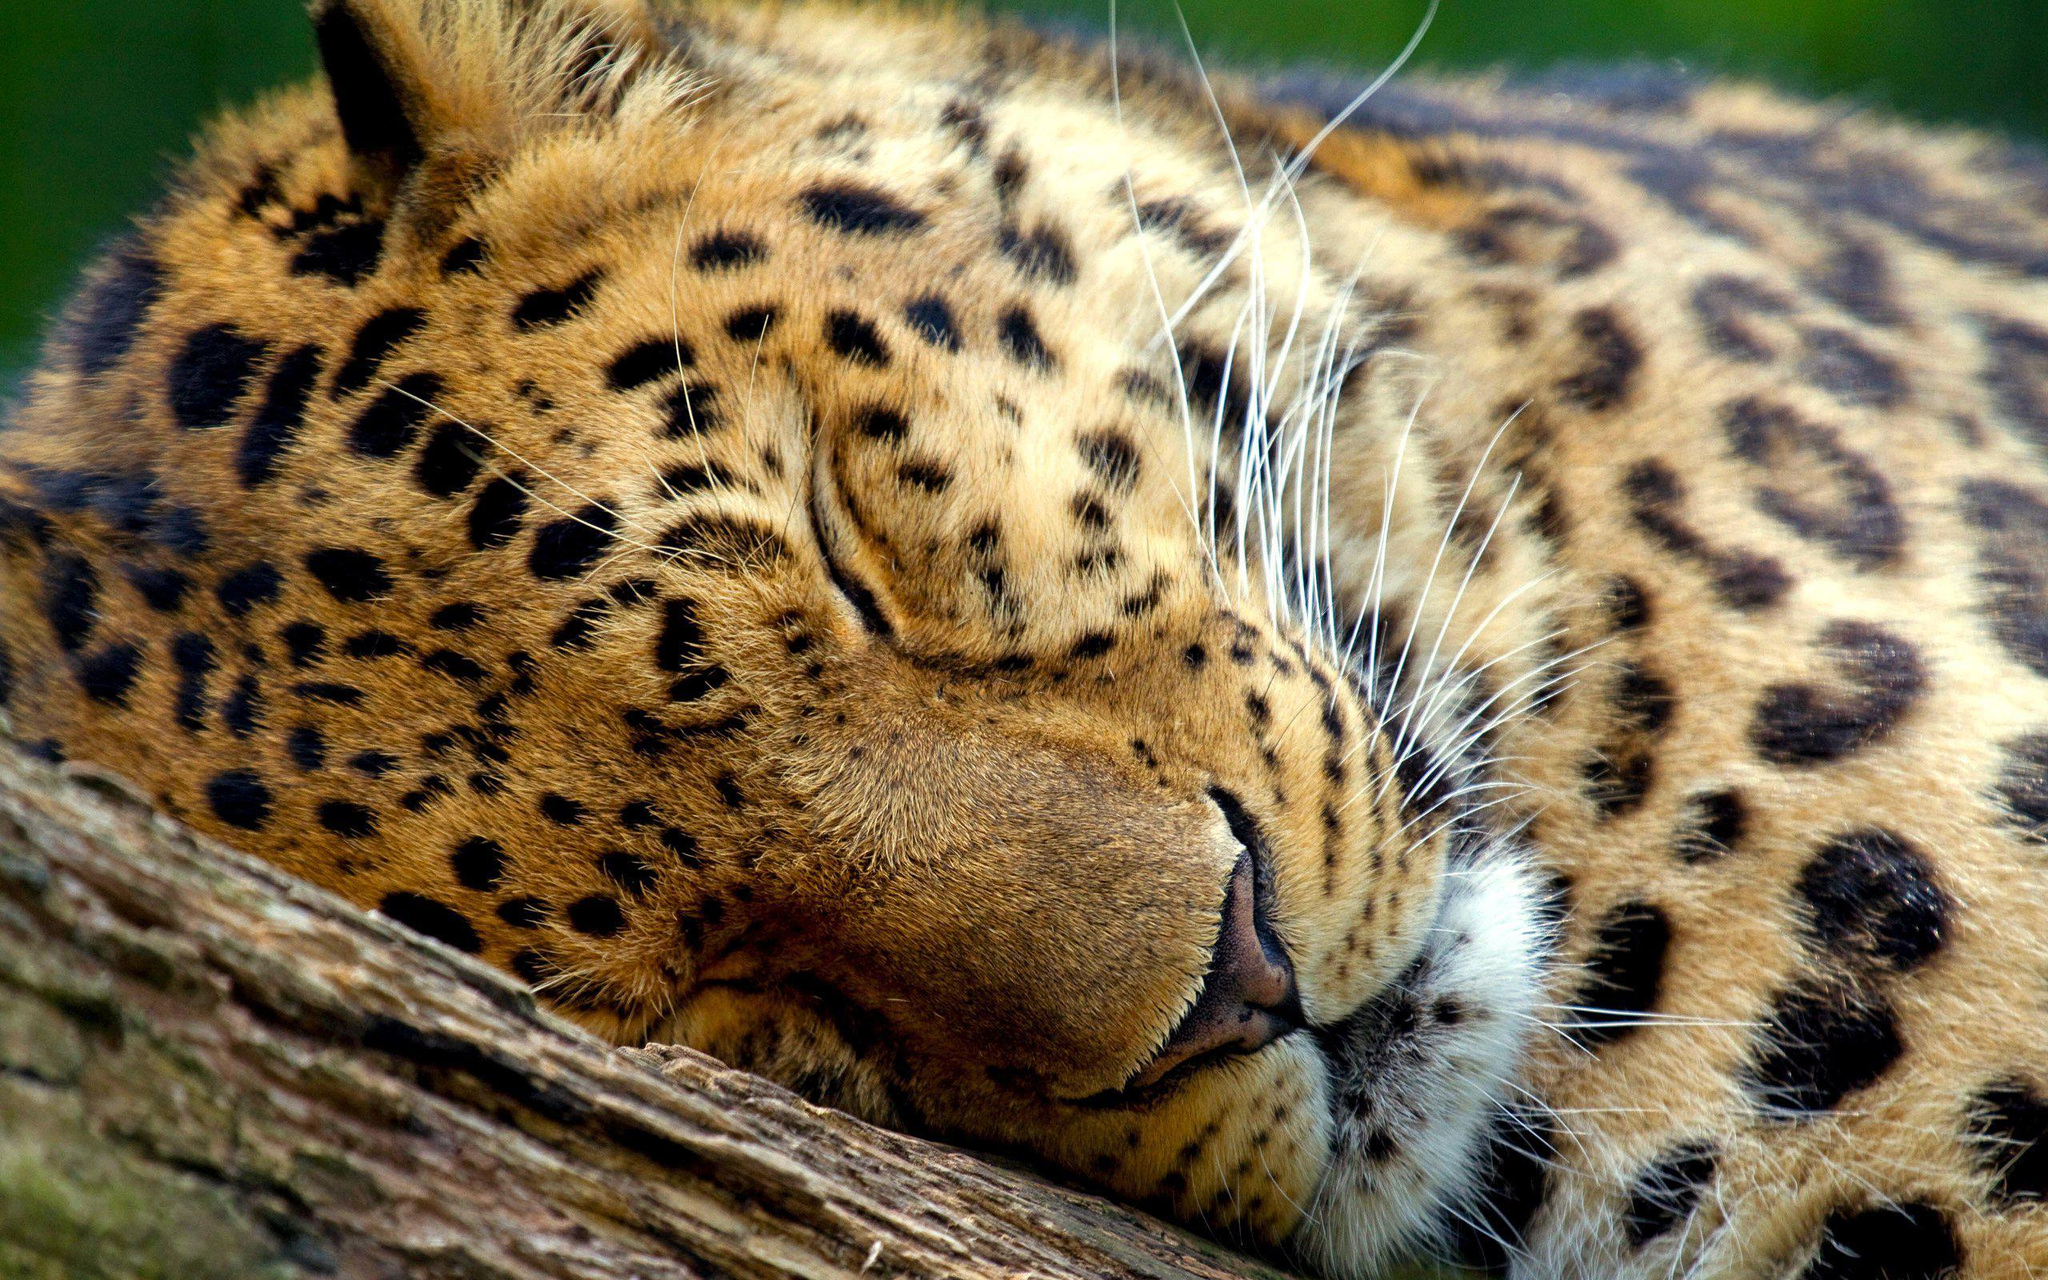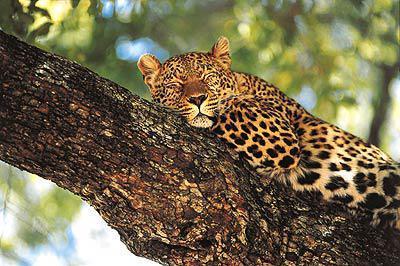The first image is the image on the left, the second image is the image on the right. Examine the images to the left and right. Is the description "In at least one image there is a spotted leopard sleeping with his head on a large branch hiding their second ear." accurate? Answer yes or no. Yes. The first image is the image on the left, the second image is the image on the right. For the images shown, is this caption "Only one of the two leopards is asleep, and neither is showing its tongue." true? Answer yes or no. No. 